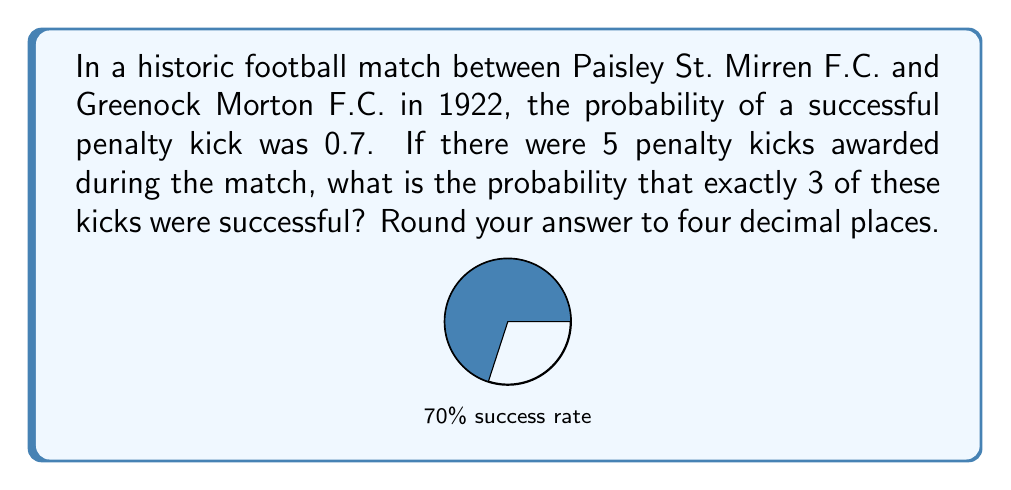Provide a solution to this math problem. To solve this problem, we'll use the binomial distribution formula:

$$P(X = k) = \binom{n}{k} p^k (1-p)^{n-k}$$

Where:
$n$ = number of trials (penalty kicks)
$k$ = number of successes
$p$ = probability of success on each trial

Given:
$n = 5$ (total penalty kicks)
$k = 3$ (successful kicks we're interested in)
$p = 0.7$ (probability of a successful kick)

Step 1: Calculate $\binom{n}{k}$
$$\binom{5}{3} = \frac{5!}{3!(5-3)!} = \frac{5 \cdot 4}{2 \cdot 1} = 10$$

Step 2: Calculate $p^k$
$$0.7^3 = 0.343$$

Step 3: Calculate $(1-p)^{n-k}$
$$(1-0.7)^{5-3} = 0.3^2 = 0.09$$

Step 4: Multiply the results from steps 1, 2, and 3
$$10 \cdot 0.343 \cdot 0.09 = 0.3087$$

Step 5: Round to four decimal places
$$0.3087 \approx 0.3087$$
Answer: 0.3087 